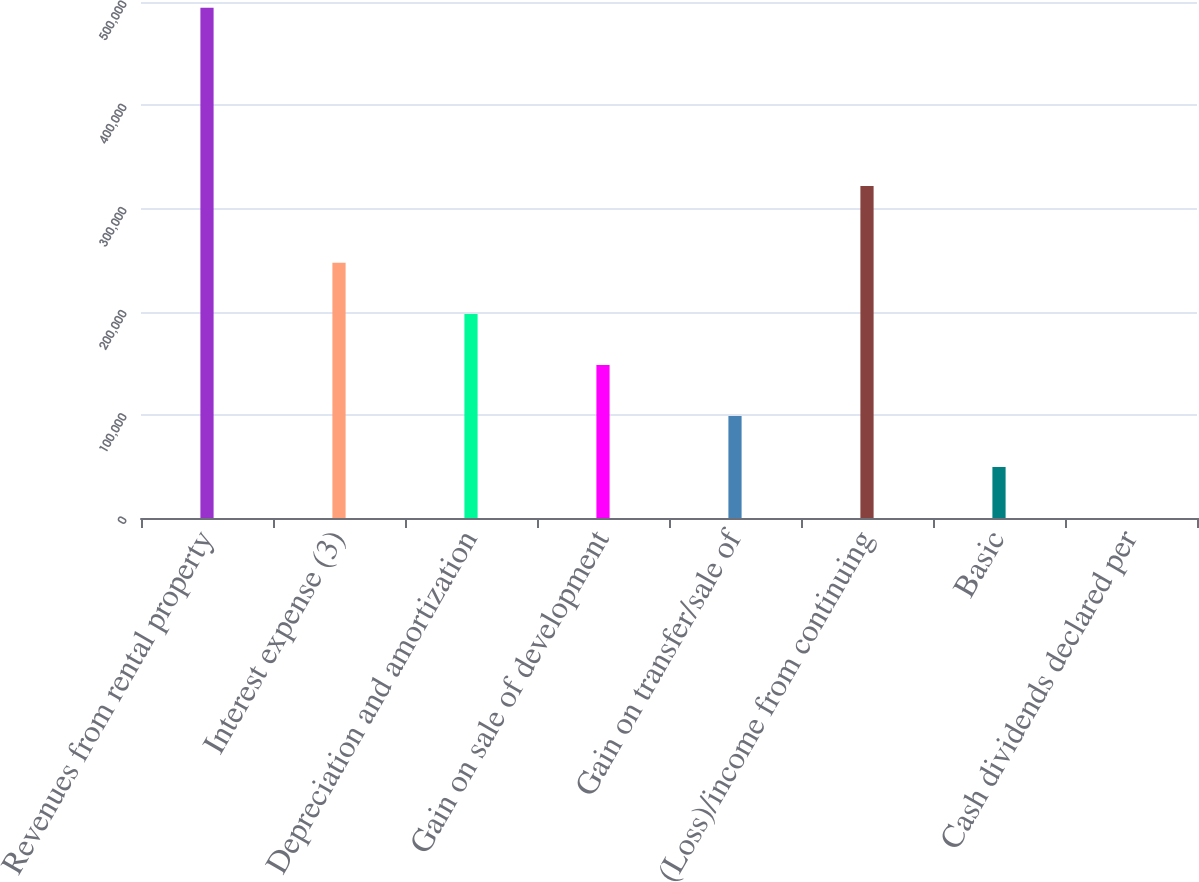<chart> <loc_0><loc_0><loc_500><loc_500><bar_chart><fcel>Revenues from rental property<fcel>Interest expense (3)<fcel>Depreciation and amortization<fcel>Gain on sale of development<fcel>Gain on transfer/sale of<fcel>(Loss)/income from continuing<fcel>Basic<fcel>Cash dividends declared per<nl><fcel>494467<fcel>247234<fcel>197788<fcel>148341<fcel>98894.4<fcel>321646<fcel>49447.8<fcel>1.27<nl></chart> 